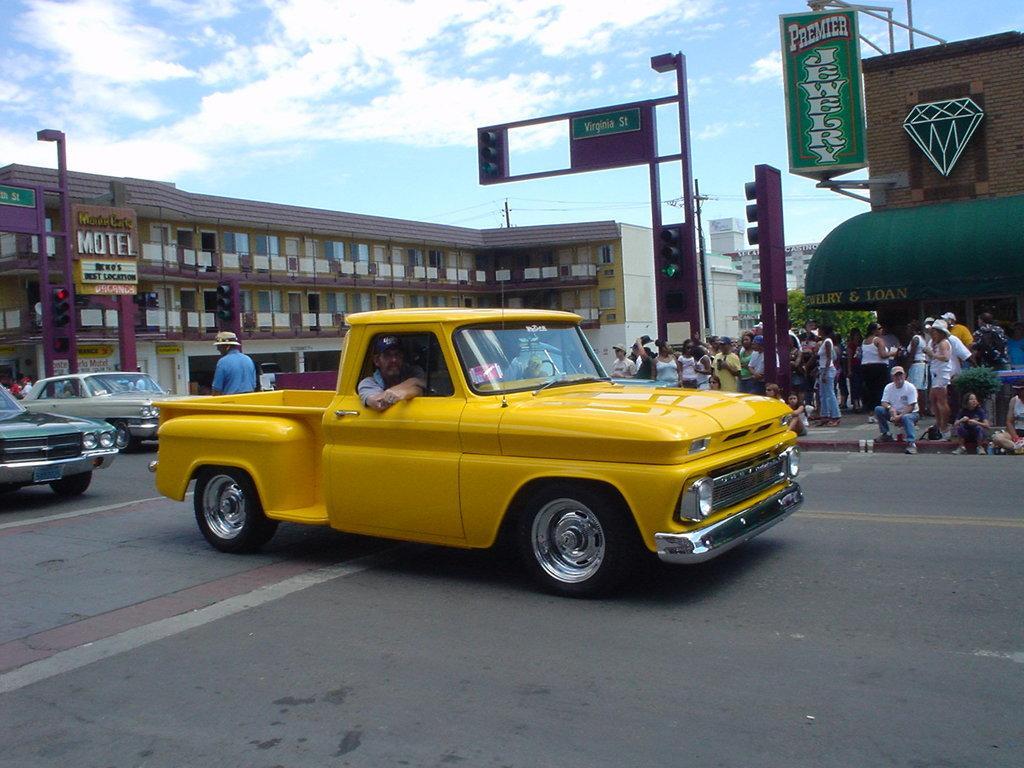Please provide a concise description of this image. There are vehicles on the road, on which there is a person. In the background, there are persons on the footpath, there are lights attached to the poles, there are hoardings, buildings and there are clouds in the blue sky. 